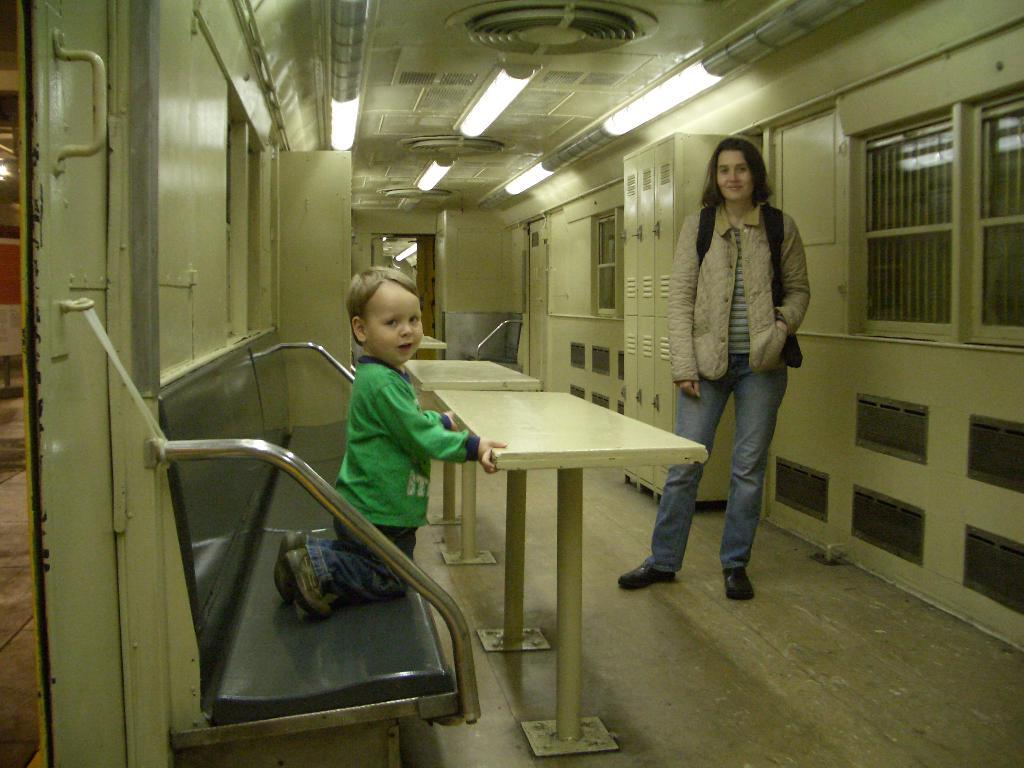What is the gender of the person in the image? The person in the image is a lady. What type of clothing is the lady person wearing? The lady person is wearing a sweater. What is the lady person carrying in the image? The lady person is carrying a backpack. Where is the lady person standing in the image? The lady person is standing on the floor. Can you describe the position of the kid in the image? The kid is kneeling on a bench. Where is the bench located in the image? The bench is on the left side of the image. What type of scarecrow can be seen in the image? There is no scarecrow present in the image. Can you tell me how many boats are docked at the harbor in the image? There is no harbor or boats present in the image. 